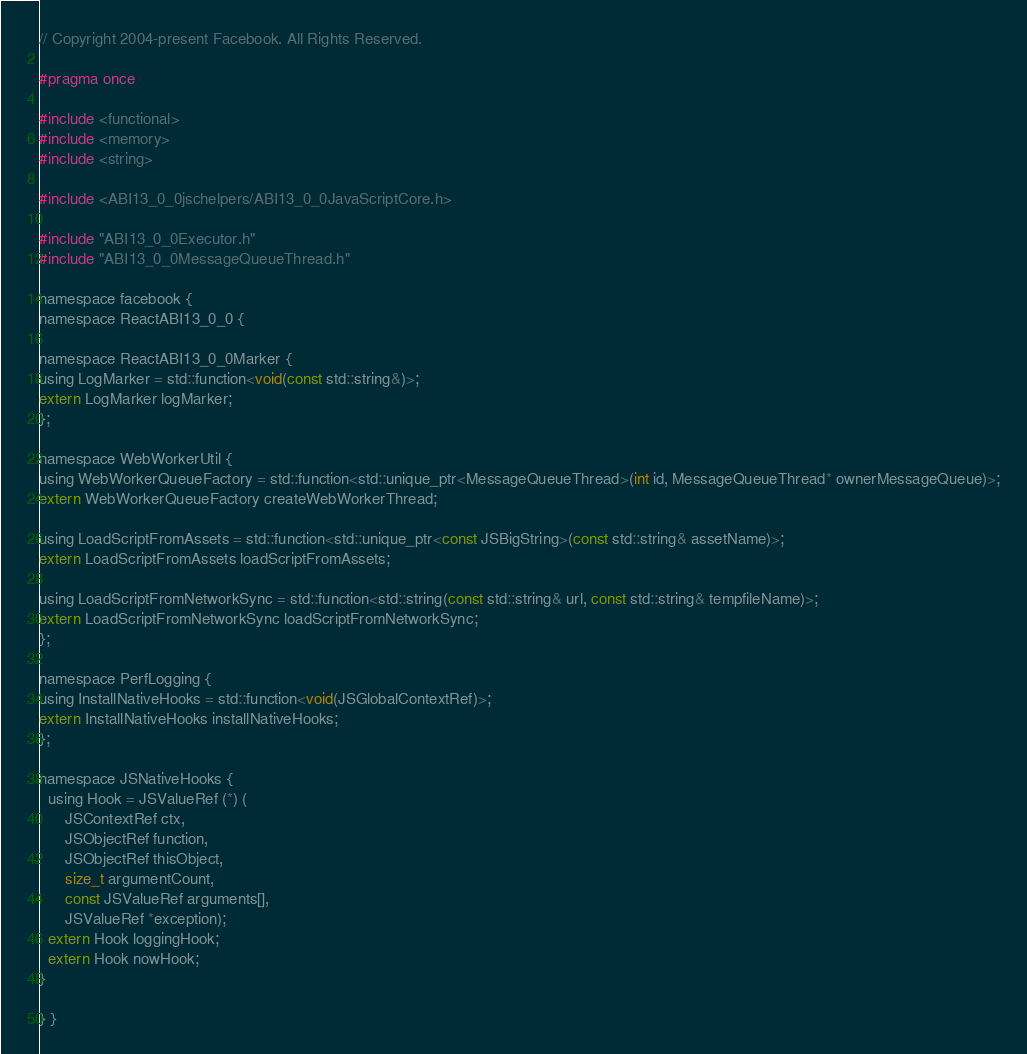Convert code to text. <code><loc_0><loc_0><loc_500><loc_500><_C_>// Copyright 2004-present Facebook. All Rights Reserved.

#pragma once

#include <functional>
#include <memory>
#include <string>

#include <ABI13_0_0jschelpers/ABI13_0_0JavaScriptCore.h>

#include "ABI13_0_0Executor.h"
#include "ABI13_0_0MessageQueueThread.h"

namespace facebook {
namespace ReactABI13_0_0 {

namespace ReactABI13_0_0Marker {
using LogMarker = std::function<void(const std::string&)>;
extern LogMarker logMarker;
};

namespace WebWorkerUtil {
using WebWorkerQueueFactory = std::function<std::unique_ptr<MessageQueueThread>(int id, MessageQueueThread* ownerMessageQueue)>;
extern WebWorkerQueueFactory createWebWorkerThread;

using LoadScriptFromAssets = std::function<std::unique_ptr<const JSBigString>(const std::string& assetName)>;
extern LoadScriptFromAssets loadScriptFromAssets;

using LoadScriptFromNetworkSync = std::function<std::string(const std::string& url, const std::string& tempfileName)>;
extern LoadScriptFromNetworkSync loadScriptFromNetworkSync;
};

namespace PerfLogging {
using InstallNativeHooks = std::function<void(JSGlobalContextRef)>;
extern InstallNativeHooks installNativeHooks;
};

namespace JSNativeHooks {
  using Hook = JSValueRef (*) (
      JSContextRef ctx,
      JSObjectRef function,
      JSObjectRef thisObject,
      size_t argumentCount,
      const JSValueRef arguments[],
      JSValueRef *exception);
  extern Hook loggingHook;
  extern Hook nowHook;
}

} }
</code> 